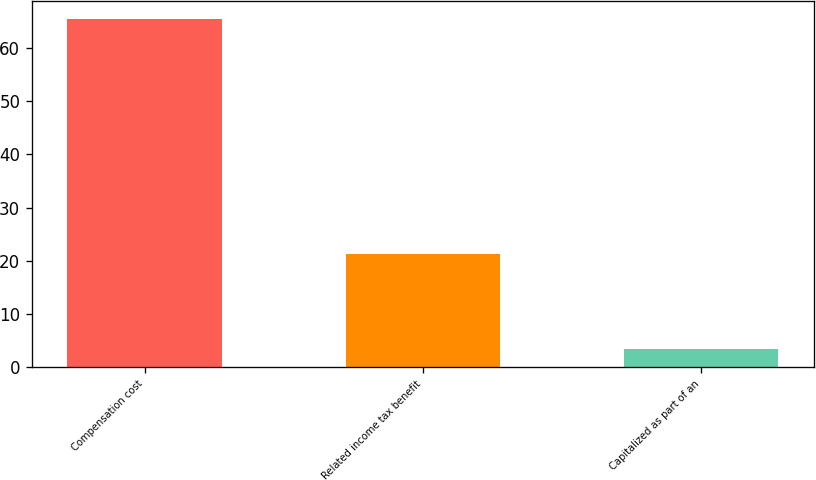Convert chart to OTSL. <chart><loc_0><loc_0><loc_500><loc_500><bar_chart><fcel>Compensation cost<fcel>Related income tax benefit<fcel>Capitalized as part of an<nl><fcel>65.5<fcel>21.3<fcel>3.4<nl></chart> 